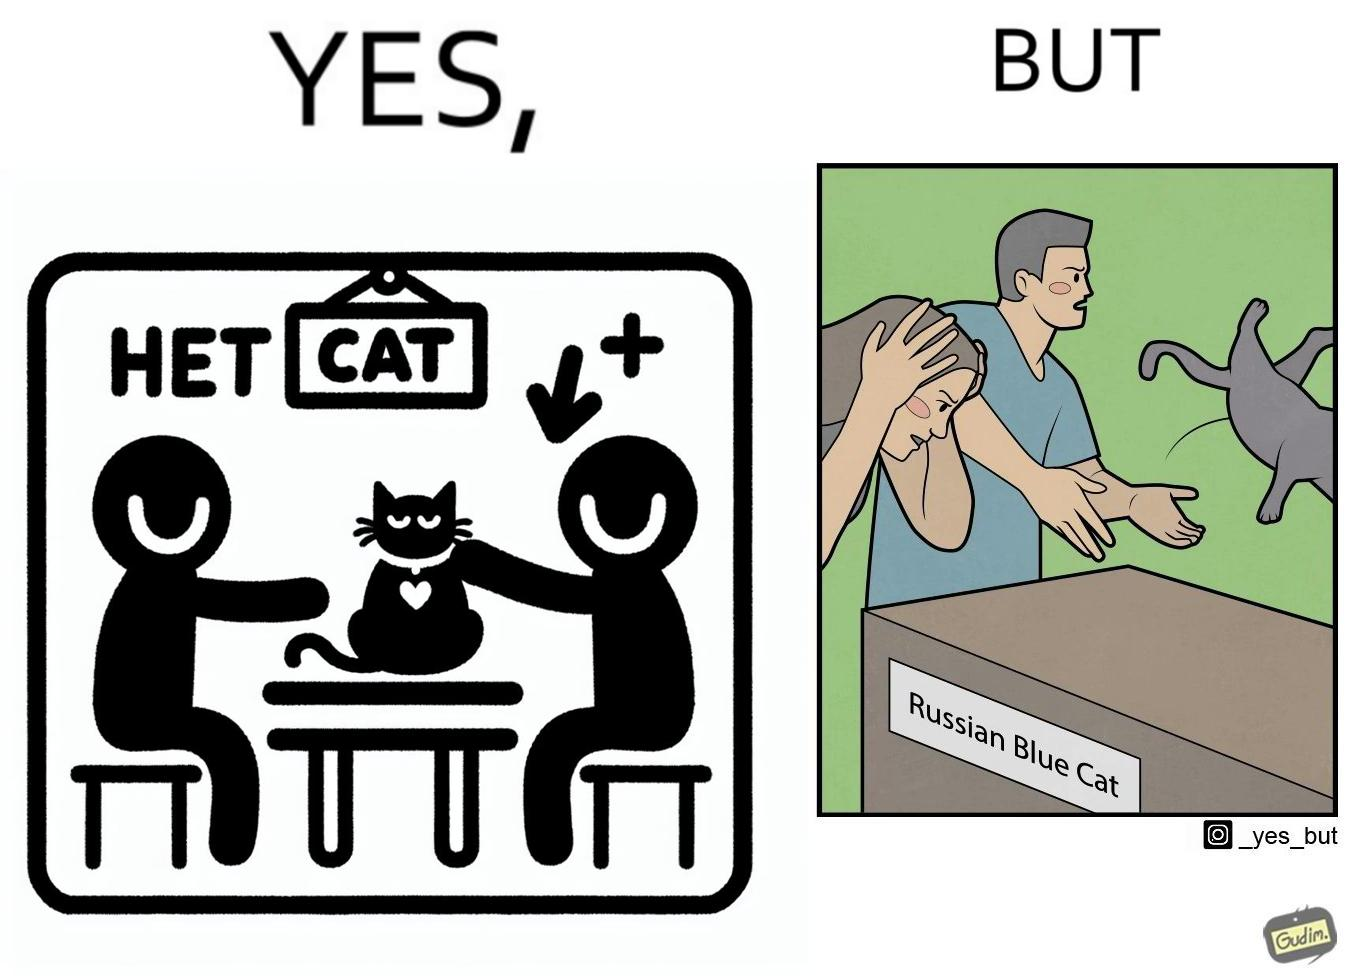What is shown in this image? The image is confusing, as initially, when the label reads "Blue Cat", the people are happy and are petting tha cat, but as soon as one of them realizes that the entire text reads "Russian Blue Cat", they seem to worried, and one of them throws away the cat. For some reason, the word "Russian" is a trigger word for them. 